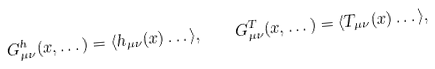Convert formula to latex. <formula><loc_0><loc_0><loc_500><loc_500>G _ { \mu \nu } ^ { h } ( x , \dots ) = \langle h _ { \mu \nu } ( x ) \dots \rangle , \quad G _ { \mu \nu } ^ { T } ( x , \dots ) = \langle T _ { \mu \nu } ( x ) \dots \rangle ,</formula> 